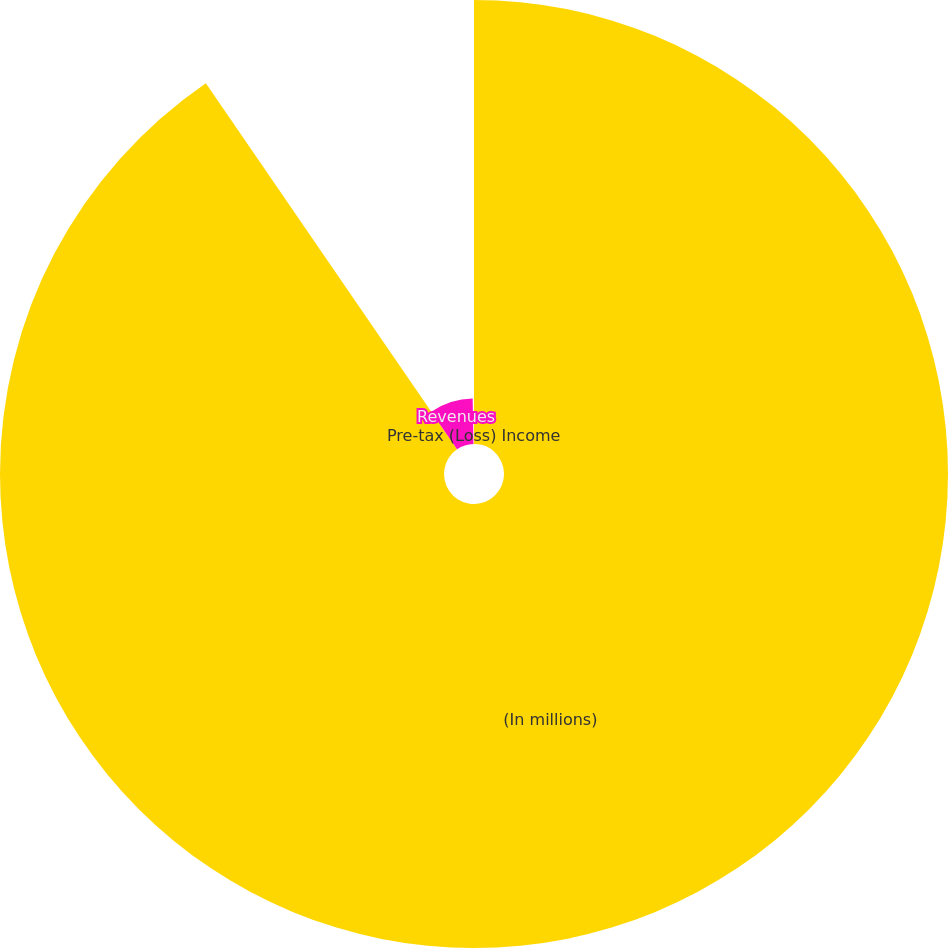<chart> <loc_0><loc_0><loc_500><loc_500><pie_chart><fcel>(In millions)<fcel>Revenues<fcel>Pre-tax (Loss) Income<nl><fcel>90.43%<fcel>9.29%<fcel>0.28%<nl></chart> 